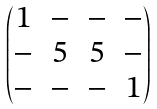<formula> <loc_0><loc_0><loc_500><loc_500>\begin{pmatrix} 1 & - & - & - \\ - & 5 & 5 & - \\ - & - & - & 1 \end{pmatrix}</formula> 